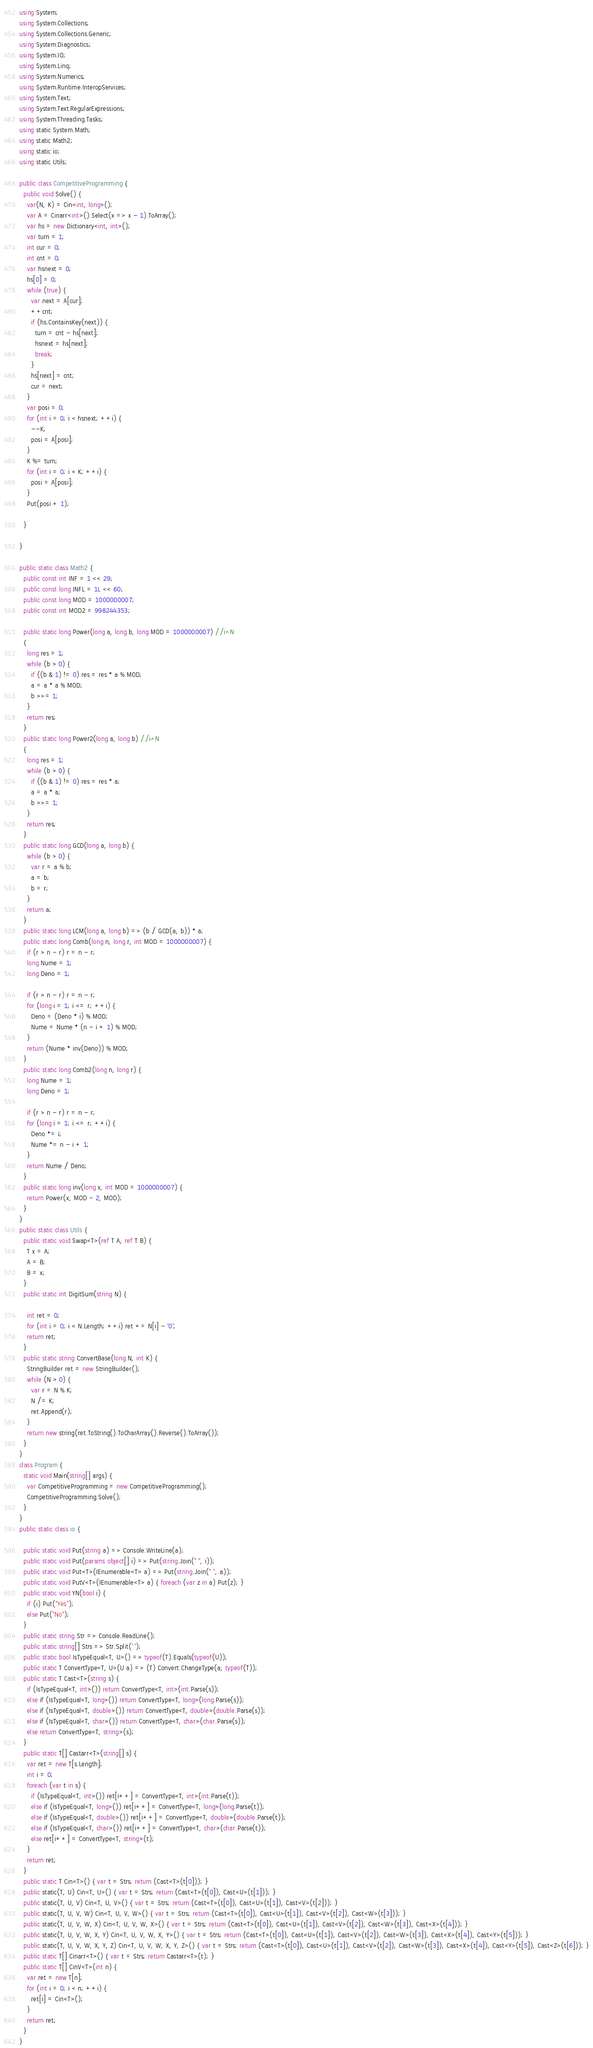<code> <loc_0><loc_0><loc_500><loc_500><_C#_>using System;
using System.Collections;
using System.Collections.Generic;
using System.Diagnostics;
using System.IO;
using System.Linq;
using System.Numerics;
using System.Runtime.InteropServices;
using System.Text;
using System.Text.RegularExpressions;
using System.Threading.Tasks;
using static System.Math;
using static Math2;
using static io;
using static Utils;

public class CompetitiveProgramming {
  public void Solve() {
    var(N, K) = Cin<int, long>();
    var A = Cinarr<int>().Select(x => x - 1).ToArray();
    var hs = new Dictionary<int, int>();
    var turn = 1;
    int cur = 0;
    int cnt = 0;
    var hsnext = 0;
    hs[0] = 0;
    while (true) {
      var next = A[cur];
      ++cnt;
      if (hs.ContainsKey(next)) {
        turn = cnt - hs[next];
        hsnext = hs[next];
        break;
      }
      hs[next] = cnt;
      cur = next;
    }
    var posi = 0;
    for (int i = 0; i < hsnext; ++i) {
      --K;
      posi = A[posi];
    }
    K %= turn;
    for (int i = 0; i < K; ++i) {
      posi = A[posi];
    }
    Put(posi + 1);

  }

}

public static class Math2 {
  public const int INF = 1 << 29;
  public const long INFL = 1L << 60;
  public const long MOD = 1000000007;
  public const int MOD2 = 998244353;

  public static long Power(long a, long b, long MOD = 1000000007) //i^N
  {
    long res = 1;
    while (b > 0) {
      if ((b & 1) != 0) res = res * a % MOD;
      a = a * a % MOD;
      b >>= 1;
    }
    return res;
  }
  public static long Power2(long a, long b) //i^N
  {
    long res = 1;
    while (b > 0) {
      if ((b & 1) != 0) res = res * a;
      a = a * a;
      b >>= 1;
    }
    return res;
  }
  public static long GCD(long a, long b) {
    while (b > 0) {
      var r = a % b;
      a = b;
      b = r;
    }
    return a;
  }
  public static long LCM(long a, long b) => (b / GCD(a, b)) * a;
  public static long Comb(long n, long r, int MOD = 1000000007) {
    if (r > n - r) r = n - r;
    long Nume = 1;
    long Deno = 1;

    if (r > n - r) r = n - r;
    for (long i = 1; i <= r; ++i) {
      Deno = (Deno * i) % MOD;
      Nume = Nume * (n - i + 1) % MOD;
    }
    return (Nume * inv(Deno)) % MOD;
  }
  public static long Comb2(long n, long r) {
    long Nume = 1;
    long Deno = 1;

    if (r > n - r) r = n - r;
    for (long i = 1; i <= r; ++i) {
      Deno *= i;
      Nume *= n - i + 1;
    }
    return Nume / Deno;
  }
  public static long inv(long x, int MOD = 1000000007) {
    return Power(x, MOD - 2, MOD);
  }
}
public static class Utils {
  public static void Swap<T>(ref T A, ref T B) {
    T x = A;
    A = B;
    B = x;
  }
  public static int DigitSum(string N) {

    int ret = 0;
    for (int i = 0; i < N.Length; ++i) ret += N[i] - '0';
    return ret;
  }
  public static string ConvertBase(long N, int K) {
    StringBuilder ret = new StringBuilder();
    while (N > 0) {
      var r = N % K;
      N /= K;
      ret.Append(r);
    }
    return new string(ret.ToString().ToCharArray().Reverse().ToArray());
  }
}
class Program {
  static void Main(string[] args) {
    var CompetitiveProgramming = new CompetitiveProgramming();
    CompetitiveProgramming.Solve();
  }
}
public static class io {

  public static void Put(string a) => Console.WriteLine(a);
  public static void Put(params object[] i) => Put(string.Join(" ", i));
  public static void Put<T>(IEnumerable<T> a) => Put(string.Join(" ", a));
  public static void PutV<T>(IEnumerable<T> a) { foreach (var z in a) Put(z); }
  public static void YN(bool i) {
    if (i) Put("Yes");
    else Put("No");
  }
  public static string Str => Console.ReadLine();
  public static string[] Strs => Str.Split(' ');
  public static bool IsTypeEqual<T, U>() => typeof(T).Equals(typeof(U));
  public static T ConvertType<T, U>(U a) => (T) Convert.ChangeType(a, typeof(T));
  public static T Cast<T>(string s) {
    if (IsTypeEqual<T, int>()) return ConvertType<T, int>(int.Parse(s));
    else if (IsTypeEqual<T, long>()) return ConvertType<T, long>(long.Parse(s));
    else if (IsTypeEqual<T, double>()) return ConvertType<T, double>(double.Parse(s));
    else if (IsTypeEqual<T, char>()) return ConvertType<T, char>(char.Parse(s));
    else return ConvertType<T, string>(s);
  }
  public static T[] Castarr<T>(string[] s) {
    var ret = new T[s.Length];
    int i = 0;
    foreach (var t in s) {
      if (IsTypeEqual<T, int>()) ret[i++] = ConvertType<T, int>(int.Parse(t));
      else if (IsTypeEqual<T, long>()) ret[i++] = ConvertType<T, long>(long.Parse(t));
      else if (IsTypeEqual<T, double>()) ret[i++] = ConvertType<T, double>(double.Parse(t));
      else if (IsTypeEqual<T, char>()) ret[i++] = ConvertType<T, char>(char.Parse(t));
      else ret[i++] = ConvertType<T, string>(t);
    }
    return ret;
  }
  public static T Cin<T>() { var t = Strs; return (Cast<T>(t[0])); }
  public static(T, U) Cin<T, U>() { var t = Strs; return (Cast<T>(t[0]), Cast<U>(t[1])); }
  public static(T, U, V) Cin<T, U, V>() { var t = Strs; return (Cast<T>(t[0]), Cast<U>(t[1]), Cast<V>(t[2])); }
  public static(T, U, V, W) Cin<T, U, V, W>() { var t = Strs; return (Cast<T>(t[0]), Cast<U>(t[1]), Cast<V>(t[2]), Cast<W>(t[3])); }
  public static(T, U, V, W, X) Cin<T, U, V, W, X>() { var t = Strs; return (Cast<T>(t[0]), Cast<U>(t[1]), Cast<V>(t[2]), Cast<W>(t[3]), Cast<X>(t[4])); }
  public static(T, U, V, W, X, Y) Cin<T, U, V, W, X, Y>() { var t = Strs; return (Cast<T>(t[0]), Cast<U>(t[1]), Cast<V>(t[2]), Cast<W>(t[3]), Cast<X>(t[4]), Cast<Y>(t[5])); }
  public static(T, U, V, W, X, Y, Z) Cin<T, U, V, W, X, Y, Z>() { var t = Strs; return (Cast<T>(t[0]), Cast<U>(t[1]), Cast<V>(t[2]), Cast<W>(t[3]), Cast<X>(t[4]), Cast<Y>(t[5]), Cast<Z>(t[6])); }
  public static T[] Cinarr<T>() { var t = Strs; return Castarr<T>(t); }
  public static T[] CinV<T>(int n) {
    var ret = new T[n];
    for (int i = 0; i < n; ++i) {
      ret[i] = Cin<T>();
    }
    return ret;
  }
}</code> 